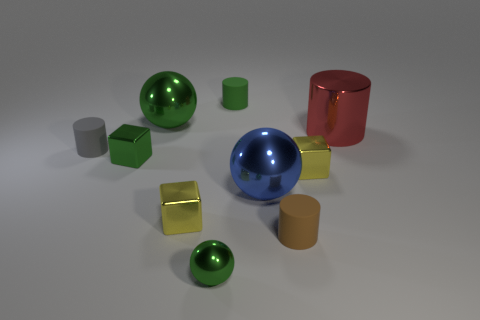Subtract all small green balls. How many balls are left? 2 Subtract all blue balls. How many balls are left? 2 Subtract all spheres. How many objects are left? 7 Subtract 1 cylinders. How many cylinders are left? 3 Subtract all red cubes. Subtract all purple spheres. How many cubes are left? 3 Subtract all purple balls. How many green blocks are left? 1 Subtract all purple shiny objects. Subtract all tiny green objects. How many objects are left? 7 Add 6 tiny green things. How many tiny green things are left? 9 Add 5 red cylinders. How many red cylinders exist? 6 Subtract 0 purple cylinders. How many objects are left? 10 